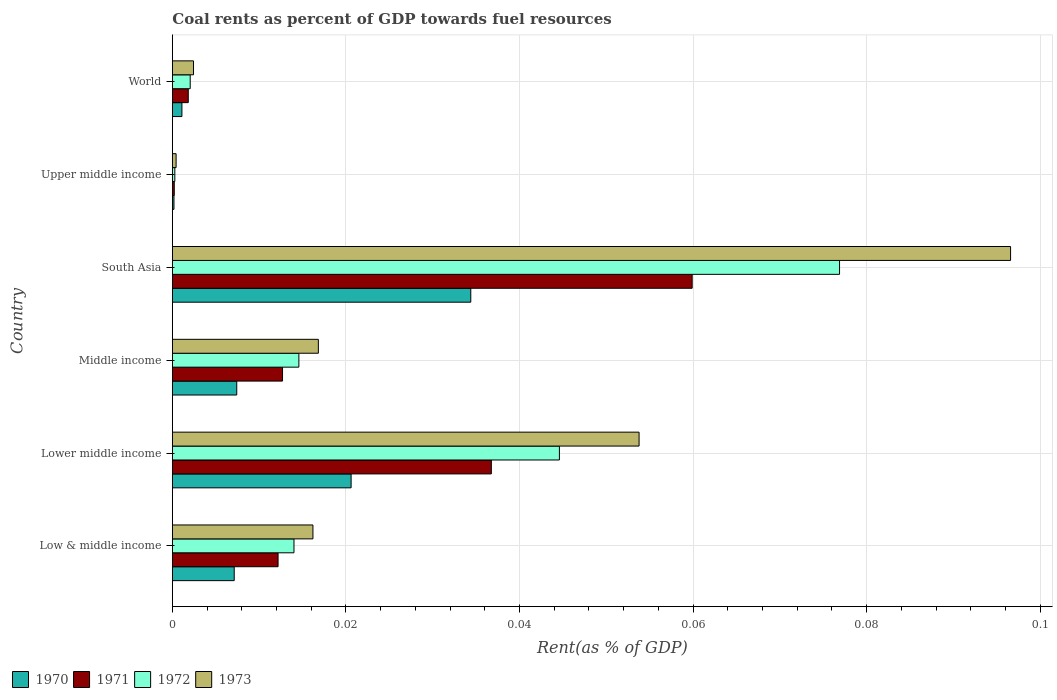How many different coloured bars are there?
Offer a terse response. 4. How many bars are there on the 3rd tick from the top?
Ensure brevity in your answer.  4. How many bars are there on the 4th tick from the bottom?
Your answer should be very brief. 4. What is the label of the 1st group of bars from the top?
Offer a terse response. World. What is the coal rent in 1972 in Middle income?
Make the answer very short. 0.01. Across all countries, what is the maximum coal rent in 1972?
Your answer should be very brief. 0.08. Across all countries, what is the minimum coal rent in 1973?
Provide a succinct answer. 0. In which country was the coal rent in 1973 maximum?
Your response must be concise. South Asia. In which country was the coal rent in 1972 minimum?
Offer a terse response. Upper middle income. What is the total coal rent in 1971 in the graph?
Give a very brief answer. 0.12. What is the difference between the coal rent in 1971 in Low & middle income and that in Lower middle income?
Ensure brevity in your answer.  -0.02. What is the difference between the coal rent in 1972 in World and the coal rent in 1971 in Low & middle income?
Provide a short and direct response. -0.01. What is the average coal rent in 1970 per country?
Make the answer very short. 0.01. What is the difference between the coal rent in 1971 and coal rent in 1973 in Low & middle income?
Offer a very short reply. -0. What is the ratio of the coal rent in 1972 in Middle income to that in World?
Offer a very short reply. 7.09. Is the coal rent in 1972 in Middle income less than that in South Asia?
Provide a succinct answer. Yes. Is the difference between the coal rent in 1971 in Lower middle income and World greater than the difference between the coal rent in 1973 in Lower middle income and World?
Provide a short and direct response. No. What is the difference between the highest and the second highest coal rent in 1971?
Offer a very short reply. 0.02. What is the difference between the highest and the lowest coal rent in 1972?
Your answer should be compact. 0.08. Is it the case that in every country, the sum of the coal rent in 1973 and coal rent in 1970 is greater than the sum of coal rent in 1971 and coal rent in 1972?
Make the answer very short. No. Does the graph contain any zero values?
Keep it short and to the point. No. Does the graph contain grids?
Provide a short and direct response. Yes. How many legend labels are there?
Your response must be concise. 4. What is the title of the graph?
Make the answer very short. Coal rents as percent of GDP towards fuel resources. What is the label or title of the X-axis?
Provide a short and direct response. Rent(as % of GDP). What is the label or title of the Y-axis?
Your answer should be very brief. Country. What is the Rent(as % of GDP) of 1970 in Low & middle income?
Keep it short and to the point. 0.01. What is the Rent(as % of GDP) in 1971 in Low & middle income?
Provide a short and direct response. 0.01. What is the Rent(as % of GDP) in 1972 in Low & middle income?
Your answer should be compact. 0.01. What is the Rent(as % of GDP) of 1973 in Low & middle income?
Offer a very short reply. 0.02. What is the Rent(as % of GDP) in 1970 in Lower middle income?
Offer a terse response. 0.02. What is the Rent(as % of GDP) of 1971 in Lower middle income?
Offer a terse response. 0.04. What is the Rent(as % of GDP) in 1972 in Lower middle income?
Provide a short and direct response. 0.04. What is the Rent(as % of GDP) in 1973 in Lower middle income?
Keep it short and to the point. 0.05. What is the Rent(as % of GDP) of 1970 in Middle income?
Provide a succinct answer. 0.01. What is the Rent(as % of GDP) of 1971 in Middle income?
Make the answer very short. 0.01. What is the Rent(as % of GDP) of 1972 in Middle income?
Give a very brief answer. 0.01. What is the Rent(as % of GDP) in 1973 in Middle income?
Ensure brevity in your answer.  0.02. What is the Rent(as % of GDP) of 1970 in South Asia?
Your response must be concise. 0.03. What is the Rent(as % of GDP) of 1971 in South Asia?
Your answer should be compact. 0.06. What is the Rent(as % of GDP) in 1972 in South Asia?
Make the answer very short. 0.08. What is the Rent(as % of GDP) in 1973 in South Asia?
Ensure brevity in your answer.  0.1. What is the Rent(as % of GDP) of 1970 in Upper middle income?
Make the answer very short. 0. What is the Rent(as % of GDP) of 1971 in Upper middle income?
Give a very brief answer. 0. What is the Rent(as % of GDP) of 1972 in Upper middle income?
Provide a succinct answer. 0. What is the Rent(as % of GDP) in 1973 in Upper middle income?
Provide a short and direct response. 0. What is the Rent(as % of GDP) in 1970 in World?
Offer a very short reply. 0. What is the Rent(as % of GDP) in 1971 in World?
Keep it short and to the point. 0. What is the Rent(as % of GDP) in 1972 in World?
Provide a succinct answer. 0. What is the Rent(as % of GDP) in 1973 in World?
Make the answer very short. 0. Across all countries, what is the maximum Rent(as % of GDP) of 1970?
Your response must be concise. 0.03. Across all countries, what is the maximum Rent(as % of GDP) in 1971?
Offer a terse response. 0.06. Across all countries, what is the maximum Rent(as % of GDP) of 1972?
Your answer should be very brief. 0.08. Across all countries, what is the maximum Rent(as % of GDP) in 1973?
Provide a succinct answer. 0.1. Across all countries, what is the minimum Rent(as % of GDP) of 1970?
Provide a succinct answer. 0. Across all countries, what is the minimum Rent(as % of GDP) of 1971?
Offer a terse response. 0. Across all countries, what is the minimum Rent(as % of GDP) in 1972?
Make the answer very short. 0. Across all countries, what is the minimum Rent(as % of GDP) in 1973?
Give a very brief answer. 0. What is the total Rent(as % of GDP) of 1970 in the graph?
Your response must be concise. 0.07. What is the total Rent(as % of GDP) of 1971 in the graph?
Provide a succinct answer. 0.12. What is the total Rent(as % of GDP) of 1972 in the graph?
Keep it short and to the point. 0.15. What is the total Rent(as % of GDP) of 1973 in the graph?
Keep it short and to the point. 0.19. What is the difference between the Rent(as % of GDP) of 1970 in Low & middle income and that in Lower middle income?
Ensure brevity in your answer.  -0.01. What is the difference between the Rent(as % of GDP) in 1971 in Low & middle income and that in Lower middle income?
Offer a very short reply. -0.02. What is the difference between the Rent(as % of GDP) in 1972 in Low & middle income and that in Lower middle income?
Your response must be concise. -0.03. What is the difference between the Rent(as % of GDP) in 1973 in Low & middle income and that in Lower middle income?
Give a very brief answer. -0.04. What is the difference between the Rent(as % of GDP) in 1970 in Low & middle income and that in Middle income?
Offer a very short reply. -0. What is the difference between the Rent(as % of GDP) in 1971 in Low & middle income and that in Middle income?
Your answer should be compact. -0. What is the difference between the Rent(as % of GDP) of 1972 in Low & middle income and that in Middle income?
Your answer should be compact. -0. What is the difference between the Rent(as % of GDP) in 1973 in Low & middle income and that in Middle income?
Ensure brevity in your answer.  -0. What is the difference between the Rent(as % of GDP) in 1970 in Low & middle income and that in South Asia?
Your answer should be very brief. -0.03. What is the difference between the Rent(as % of GDP) in 1971 in Low & middle income and that in South Asia?
Provide a short and direct response. -0.05. What is the difference between the Rent(as % of GDP) of 1972 in Low & middle income and that in South Asia?
Offer a very short reply. -0.06. What is the difference between the Rent(as % of GDP) of 1973 in Low & middle income and that in South Asia?
Keep it short and to the point. -0.08. What is the difference between the Rent(as % of GDP) of 1970 in Low & middle income and that in Upper middle income?
Your answer should be compact. 0.01. What is the difference between the Rent(as % of GDP) of 1971 in Low & middle income and that in Upper middle income?
Your response must be concise. 0.01. What is the difference between the Rent(as % of GDP) in 1972 in Low & middle income and that in Upper middle income?
Your answer should be compact. 0.01. What is the difference between the Rent(as % of GDP) of 1973 in Low & middle income and that in Upper middle income?
Keep it short and to the point. 0.02. What is the difference between the Rent(as % of GDP) in 1970 in Low & middle income and that in World?
Provide a short and direct response. 0.01. What is the difference between the Rent(as % of GDP) of 1971 in Low & middle income and that in World?
Your answer should be compact. 0.01. What is the difference between the Rent(as % of GDP) in 1972 in Low & middle income and that in World?
Offer a terse response. 0.01. What is the difference between the Rent(as % of GDP) of 1973 in Low & middle income and that in World?
Make the answer very short. 0.01. What is the difference between the Rent(as % of GDP) in 1970 in Lower middle income and that in Middle income?
Offer a very short reply. 0.01. What is the difference between the Rent(as % of GDP) of 1971 in Lower middle income and that in Middle income?
Provide a succinct answer. 0.02. What is the difference between the Rent(as % of GDP) of 1973 in Lower middle income and that in Middle income?
Your answer should be compact. 0.04. What is the difference between the Rent(as % of GDP) in 1970 in Lower middle income and that in South Asia?
Provide a succinct answer. -0.01. What is the difference between the Rent(as % of GDP) in 1971 in Lower middle income and that in South Asia?
Provide a short and direct response. -0.02. What is the difference between the Rent(as % of GDP) in 1972 in Lower middle income and that in South Asia?
Ensure brevity in your answer.  -0.03. What is the difference between the Rent(as % of GDP) of 1973 in Lower middle income and that in South Asia?
Ensure brevity in your answer.  -0.04. What is the difference between the Rent(as % of GDP) in 1970 in Lower middle income and that in Upper middle income?
Your answer should be compact. 0.02. What is the difference between the Rent(as % of GDP) in 1971 in Lower middle income and that in Upper middle income?
Ensure brevity in your answer.  0.04. What is the difference between the Rent(as % of GDP) in 1972 in Lower middle income and that in Upper middle income?
Provide a short and direct response. 0.04. What is the difference between the Rent(as % of GDP) of 1973 in Lower middle income and that in Upper middle income?
Keep it short and to the point. 0.05. What is the difference between the Rent(as % of GDP) of 1970 in Lower middle income and that in World?
Provide a succinct answer. 0.02. What is the difference between the Rent(as % of GDP) in 1971 in Lower middle income and that in World?
Your answer should be very brief. 0.03. What is the difference between the Rent(as % of GDP) in 1972 in Lower middle income and that in World?
Provide a succinct answer. 0.04. What is the difference between the Rent(as % of GDP) of 1973 in Lower middle income and that in World?
Give a very brief answer. 0.05. What is the difference between the Rent(as % of GDP) in 1970 in Middle income and that in South Asia?
Ensure brevity in your answer.  -0.03. What is the difference between the Rent(as % of GDP) in 1971 in Middle income and that in South Asia?
Give a very brief answer. -0.05. What is the difference between the Rent(as % of GDP) in 1972 in Middle income and that in South Asia?
Offer a very short reply. -0.06. What is the difference between the Rent(as % of GDP) in 1973 in Middle income and that in South Asia?
Provide a succinct answer. -0.08. What is the difference between the Rent(as % of GDP) in 1970 in Middle income and that in Upper middle income?
Provide a succinct answer. 0.01. What is the difference between the Rent(as % of GDP) in 1971 in Middle income and that in Upper middle income?
Your response must be concise. 0.01. What is the difference between the Rent(as % of GDP) in 1972 in Middle income and that in Upper middle income?
Give a very brief answer. 0.01. What is the difference between the Rent(as % of GDP) of 1973 in Middle income and that in Upper middle income?
Offer a very short reply. 0.02. What is the difference between the Rent(as % of GDP) in 1970 in Middle income and that in World?
Your answer should be compact. 0.01. What is the difference between the Rent(as % of GDP) in 1971 in Middle income and that in World?
Give a very brief answer. 0.01. What is the difference between the Rent(as % of GDP) in 1972 in Middle income and that in World?
Your response must be concise. 0.01. What is the difference between the Rent(as % of GDP) in 1973 in Middle income and that in World?
Your answer should be compact. 0.01. What is the difference between the Rent(as % of GDP) in 1970 in South Asia and that in Upper middle income?
Keep it short and to the point. 0.03. What is the difference between the Rent(as % of GDP) of 1971 in South Asia and that in Upper middle income?
Offer a terse response. 0.06. What is the difference between the Rent(as % of GDP) in 1972 in South Asia and that in Upper middle income?
Offer a very short reply. 0.08. What is the difference between the Rent(as % of GDP) in 1973 in South Asia and that in Upper middle income?
Provide a succinct answer. 0.1. What is the difference between the Rent(as % of GDP) in 1970 in South Asia and that in World?
Make the answer very short. 0.03. What is the difference between the Rent(as % of GDP) of 1971 in South Asia and that in World?
Your answer should be very brief. 0.06. What is the difference between the Rent(as % of GDP) of 1972 in South Asia and that in World?
Your response must be concise. 0.07. What is the difference between the Rent(as % of GDP) of 1973 in South Asia and that in World?
Provide a succinct answer. 0.09. What is the difference between the Rent(as % of GDP) of 1970 in Upper middle income and that in World?
Your answer should be very brief. -0. What is the difference between the Rent(as % of GDP) of 1971 in Upper middle income and that in World?
Offer a very short reply. -0. What is the difference between the Rent(as % of GDP) of 1972 in Upper middle income and that in World?
Keep it short and to the point. -0. What is the difference between the Rent(as % of GDP) of 1973 in Upper middle income and that in World?
Ensure brevity in your answer.  -0. What is the difference between the Rent(as % of GDP) in 1970 in Low & middle income and the Rent(as % of GDP) in 1971 in Lower middle income?
Offer a very short reply. -0.03. What is the difference between the Rent(as % of GDP) in 1970 in Low & middle income and the Rent(as % of GDP) in 1972 in Lower middle income?
Ensure brevity in your answer.  -0.04. What is the difference between the Rent(as % of GDP) of 1970 in Low & middle income and the Rent(as % of GDP) of 1973 in Lower middle income?
Give a very brief answer. -0.05. What is the difference between the Rent(as % of GDP) in 1971 in Low & middle income and the Rent(as % of GDP) in 1972 in Lower middle income?
Provide a short and direct response. -0.03. What is the difference between the Rent(as % of GDP) in 1971 in Low & middle income and the Rent(as % of GDP) in 1973 in Lower middle income?
Offer a very short reply. -0.04. What is the difference between the Rent(as % of GDP) of 1972 in Low & middle income and the Rent(as % of GDP) of 1973 in Lower middle income?
Your answer should be compact. -0.04. What is the difference between the Rent(as % of GDP) in 1970 in Low & middle income and the Rent(as % of GDP) in 1971 in Middle income?
Ensure brevity in your answer.  -0.01. What is the difference between the Rent(as % of GDP) of 1970 in Low & middle income and the Rent(as % of GDP) of 1972 in Middle income?
Keep it short and to the point. -0.01. What is the difference between the Rent(as % of GDP) in 1970 in Low & middle income and the Rent(as % of GDP) in 1973 in Middle income?
Your answer should be compact. -0.01. What is the difference between the Rent(as % of GDP) of 1971 in Low & middle income and the Rent(as % of GDP) of 1972 in Middle income?
Provide a short and direct response. -0. What is the difference between the Rent(as % of GDP) in 1971 in Low & middle income and the Rent(as % of GDP) in 1973 in Middle income?
Offer a very short reply. -0. What is the difference between the Rent(as % of GDP) in 1972 in Low & middle income and the Rent(as % of GDP) in 1973 in Middle income?
Ensure brevity in your answer.  -0. What is the difference between the Rent(as % of GDP) of 1970 in Low & middle income and the Rent(as % of GDP) of 1971 in South Asia?
Offer a terse response. -0.05. What is the difference between the Rent(as % of GDP) in 1970 in Low & middle income and the Rent(as % of GDP) in 1972 in South Asia?
Your answer should be very brief. -0.07. What is the difference between the Rent(as % of GDP) of 1970 in Low & middle income and the Rent(as % of GDP) of 1973 in South Asia?
Make the answer very short. -0.09. What is the difference between the Rent(as % of GDP) of 1971 in Low & middle income and the Rent(as % of GDP) of 1972 in South Asia?
Give a very brief answer. -0.06. What is the difference between the Rent(as % of GDP) of 1971 in Low & middle income and the Rent(as % of GDP) of 1973 in South Asia?
Your answer should be very brief. -0.08. What is the difference between the Rent(as % of GDP) in 1972 in Low & middle income and the Rent(as % of GDP) in 1973 in South Asia?
Offer a very short reply. -0.08. What is the difference between the Rent(as % of GDP) in 1970 in Low & middle income and the Rent(as % of GDP) in 1971 in Upper middle income?
Your answer should be very brief. 0.01. What is the difference between the Rent(as % of GDP) of 1970 in Low & middle income and the Rent(as % of GDP) of 1972 in Upper middle income?
Your answer should be very brief. 0.01. What is the difference between the Rent(as % of GDP) of 1970 in Low & middle income and the Rent(as % of GDP) of 1973 in Upper middle income?
Provide a succinct answer. 0.01. What is the difference between the Rent(as % of GDP) in 1971 in Low & middle income and the Rent(as % of GDP) in 1972 in Upper middle income?
Keep it short and to the point. 0.01. What is the difference between the Rent(as % of GDP) in 1971 in Low & middle income and the Rent(as % of GDP) in 1973 in Upper middle income?
Provide a short and direct response. 0.01. What is the difference between the Rent(as % of GDP) in 1972 in Low & middle income and the Rent(as % of GDP) in 1973 in Upper middle income?
Keep it short and to the point. 0.01. What is the difference between the Rent(as % of GDP) of 1970 in Low & middle income and the Rent(as % of GDP) of 1971 in World?
Give a very brief answer. 0.01. What is the difference between the Rent(as % of GDP) in 1970 in Low & middle income and the Rent(as % of GDP) in 1972 in World?
Offer a terse response. 0.01. What is the difference between the Rent(as % of GDP) of 1970 in Low & middle income and the Rent(as % of GDP) of 1973 in World?
Your answer should be very brief. 0. What is the difference between the Rent(as % of GDP) of 1971 in Low & middle income and the Rent(as % of GDP) of 1972 in World?
Your response must be concise. 0.01. What is the difference between the Rent(as % of GDP) in 1971 in Low & middle income and the Rent(as % of GDP) in 1973 in World?
Your response must be concise. 0.01. What is the difference between the Rent(as % of GDP) in 1972 in Low & middle income and the Rent(as % of GDP) in 1973 in World?
Your answer should be very brief. 0.01. What is the difference between the Rent(as % of GDP) in 1970 in Lower middle income and the Rent(as % of GDP) in 1971 in Middle income?
Give a very brief answer. 0.01. What is the difference between the Rent(as % of GDP) in 1970 in Lower middle income and the Rent(as % of GDP) in 1972 in Middle income?
Give a very brief answer. 0.01. What is the difference between the Rent(as % of GDP) of 1970 in Lower middle income and the Rent(as % of GDP) of 1973 in Middle income?
Offer a very short reply. 0. What is the difference between the Rent(as % of GDP) in 1971 in Lower middle income and the Rent(as % of GDP) in 1972 in Middle income?
Make the answer very short. 0.02. What is the difference between the Rent(as % of GDP) of 1971 in Lower middle income and the Rent(as % of GDP) of 1973 in Middle income?
Offer a very short reply. 0.02. What is the difference between the Rent(as % of GDP) of 1972 in Lower middle income and the Rent(as % of GDP) of 1973 in Middle income?
Your answer should be compact. 0.03. What is the difference between the Rent(as % of GDP) of 1970 in Lower middle income and the Rent(as % of GDP) of 1971 in South Asia?
Give a very brief answer. -0.04. What is the difference between the Rent(as % of GDP) in 1970 in Lower middle income and the Rent(as % of GDP) in 1972 in South Asia?
Offer a very short reply. -0.06. What is the difference between the Rent(as % of GDP) in 1970 in Lower middle income and the Rent(as % of GDP) in 1973 in South Asia?
Provide a succinct answer. -0.08. What is the difference between the Rent(as % of GDP) of 1971 in Lower middle income and the Rent(as % of GDP) of 1972 in South Asia?
Give a very brief answer. -0.04. What is the difference between the Rent(as % of GDP) in 1971 in Lower middle income and the Rent(as % of GDP) in 1973 in South Asia?
Offer a terse response. -0.06. What is the difference between the Rent(as % of GDP) of 1972 in Lower middle income and the Rent(as % of GDP) of 1973 in South Asia?
Offer a very short reply. -0.05. What is the difference between the Rent(as % of GDP) in 1970 in Lower middle income and the Rent(as % of GDP) in 1971 in Upper middle income?
Offer a very short reply. 0.02. What is the difference between the Rent(as % of GDP) in 1970 in Lower middle income and the Rent(as % of GDP) in 1972 in Upper middle income?
Offer a terse response. 0.02. What is the difference between the Rent(as % of GDP) in 1970 in Lower middle income and the Rent(as % of GDP) in 1973 in Upper middle income?
Make the answer very short. 0.02. What is the difference between the Rent(as % of GDP) in 1971 in Lower middle income and the Rent(as % of GDP) in 1972 in Upper middle income?
Provide a succinct answer. 0.04. What is the difference between the Rent(as % of GDP) in 1971 in Lower middle income and the Rent(as % of GDP) in 1973 in Upper middle income?
Give a very brief answer. 0.04. What is the difference between the Rent(as % of GDP) of 1972 in Lower middle income and the Rent(as % of GDP) of 1973 in Upper middle income?
Ensure brevity in your answer.  0.04. What is the difference between the Rent(as % of GDP) in 1970 in Lower middle income and the Rent(as % of GDP) in 1971 in World?
Your answer should be compact. 0.02. What is the difference between the Rent(as % of GDP) of 1970 in Lower middle income and the Rent(as % of GDP) of 1972 in World?
Make the answer very short. 0.02. What is the difference between the Rent(as % of GDP) of 1970 in Lower middle income and the Rent(as % of GDP) of 1973 in World?
Your response must be concise. 0.02. What is the difference between the Rent(as % of GDP) of 1971 in Lower middle income and the Rent(as % of GDP) of 1972 in World?
Provide a short and direct response. 0.03. What is the difference between the Rent(as % of GDP) in 1971 in Lower middle income and the Rent(as % of GDP) in 1973 in World?
Offer a terse response. 0.03. What is the difference between the Rent(as % of GDP) of 1972 in Lower middle income and the Rent(as % of GDP) of 1973 in World?
Your answer should be very brief. 0.04. What is the difference between the Rent(as % of GDP) of 1970 in Middle income and the Rent(as % of GDP) of 1971 in South Asia?
Ensure brevity in your answer.  -0.05. What is the difference between the Rent(as % of GDP) in 1970 in Middle income and the Rent(as % of GDP) in 1972 in South Asia?
Give a very brief answer. -0.07. What is the difference between the Rent(as % of GDP) in 1970 in Middle income and the Rent(as % of GDP) in 1973 in South Asia?
Give a very brief answer. -0.09. What is the difference between the Rent(as % of GDP) of 1971 in Middle income and the Rent(as % of GDP) of 1972 in South Asia?
Offer a terse response. -0.06. What is the difference between the Rent(as % of GDP) of 1971 in Middle income and the Rent(as % of GDP) of 1973 in South Asia?
Make the answer very short. -0.08. What is the difference between the Rent(as % of GDP) of 1972 in Middle income and the Rent(as % of GDP) of 1973 in South Asia?
Offer a very short reply. -0.08. What is the difference between the Rent(as % of GDP) of 1970 in Middle income and the Rent(as % of GDP) of 1971 in Upper middle income?
Make the answer very short. 0.01. What is the difference between the Rent(as % of GDP) in 1970 in Middle income and the Rent(as % of GDP) in 1972 in Upper middle income?
Your response must be concise. 0.01. What is the difference between the Rent(as % of GDP) in 1970 in Middle income and the Rent(as % of GDP) in 1973 in Upper middle income?
Your response must be concise. 0.01. What is the difference between the Rent(as % of GDP) in 1971 in Middle income and the Rent(as % of GDP) in 1972 in Upper middle income?
Keep it short and to the point. 0.01. What is the difference between the Rent(as % of GDP) in 1971 in Middle income and the Rent(as % of GDP) in 1973 in Upper middle income?
Make the answer very short. 0.01. What is the difference between the Rent(as % of GDP) of 1972 in Middle income and the Rent(as % of GDP) of 1973 in Upper middle income?
Provide a short and direct response. 0.01. What is the difference between the Rent(as % of GDP) of 1970 in Middle income and the Rent(as % of GDP) of 1971 in World?
Your response must be concise. 0.01. What is the difference between the Rent(as % of GDP) in 1970 in Middle income and the Rent(as % of GDP) in 1972 in World?
Your answer should be compact. 0.01. What is the difference between the Rent(as % of GDP) of 1970 in Middle income and the Rent(as % of GDP) of 1973 in World?
Make the answer very short. 0.01. What is the difference between the Rent(as % of GDP) in 1971 in Middle income and the Rent(as % of GDP) in 1972 in World?
Offer a terse response. 0.01. What is the difference between the Rent(as % of GDP) in 1971 in Middle income and the Rent(as % of GDP) in 1973 in World?
Your answer should be compact. 0.01. What is the difference between the Rent(as % of GDP) in 1972 in Middle income and the Rent(as % of GDP) in 1973 in World?
Provide a short and direct response. 0.01. What is the difference between the Rent(as % of GDP) in 1970 in South Asia and the Rent(as % of GDP) in 1971 in Upper middle income?
Offer a terse response. 0.03. What is the difference between the Rent(as % of GDP) of 1970 in South Asia and the Rent(as % of GDP) of 1972 in Upper middle income?
Ensure brevity in your answer.  0.03. What is the difference between the Rent(as % of GDP) of 1970 in South Asia and the Rent(as % of GDP) of 1973 in Upper middle income?
Make the answer very short. 0.03. What is the difference between the Rent(as % of GDP) in 1971 in South Asia and the Rent(as % of GDP) in 1972 in Upper middle income?
Your answer should be compact. 0.06. What is the difference between the Rent(as % of GDP) in 1971 in South Asia and the Rent(as % of GDP) in 1973 in Upper middle income?
Keep it short and to the point. 0.06. What is the difference between the Rent(as % of GDP) in 1972 in South Asia and the Rent(as % of GDP) in 1973 in Upper middle income?
Offer a very short reply. 0.08. What is the difference between the Rent(as % of GDP) of 1970 in South Asia and the Rent(as % of GDP) of 1971 in World?
Ensure brevity in your answer.  0.03. What is the difference between the Rent(as % of GDP) of 1970 in South Asia and the Rent(as % of GDP) of 1972 in World?
Offer a terse response. 0.03. What is the difference between the Rent(as % of GDP) of 1970 in South Asia and the Rent(as % of GDP) of 1973 in World?
Your answer should be compact. 0.03. What is the difference between the Rent(as % of GDP) in 1971 in South Asia and the Rent(as % of GDP) in 1972 in World?
Give a very brief answer. 0.06. What is the difference between the Rent(as % of GDP) in 1971 in South Asia and the Rent(as % of GDP) in 1973 in World?
Your answer should be very brief. 0.06. What is the difference between the Rent(as % of GDP) in 1972 in South Asia and the Rent(as % of GDP) in 1973 in World?
Give a very brief answer. 0.07. What is the difference between the Rent(as % of GDP) of 1970 in Upper middle income and the Rent(as % of GDP) of 1971 in World?
Offer a very short reply. -0. What is the difference between the Rent(as % of GDP) of 1970 in Upper middle income and the Rent(as % of GDP) of 1972 in World?
Give a very brief answer. -0. What is the difference between the Rent(as % of GDP) in 1970 in Upper middle income and the Rent(as % of GDP) in 1973 in World?
Offer a terse response. -0. What is the difference between the Rent(as % of GDP) of 1971 in Upper middle income and the Rent(as % of GDP) of 1972 in World?
Your answer should be very brief. -0. What is the difference between the Rent(as % of GDP) in 1971 in Upper middle income and the Rent(as % of GDP) in 1973 in World?
Your answer should be very brief. -0. What is the difference between the Rent(as % of GDP) of 1972 in Upper middle income and the Rent(as % of GDP) of 1973 in World?
Ensure brevity in your answer.  -0. What is the average Rent(as % of GDP) in 1970 per country?
Offer a terse response. 0.01. What is the average Rent(as % of GDP) of 1971 per country?
Offer a terse response. 0.02. What is the average Rent(as % of GDP) of 1972 per country?
Give a very brief answer. 0.03. What is the average Rent(as % of GDP) in 1973 per country?
Keep it short and to the point. 0.03. What is the difference between the Rent(as % of GDP) in 1970 and Rent(as % of GDP) in 1971 in Low & middle income?
Your response must be concise. -0.01. What is the difference between the Rent(as % of GDP) in 1970 and Rent(as % of GDP) in 1972 in Low & middle income?
Your answer should be compact. -0.01. What is the difference between the Rent(as % of GDP) in 1970 and Rent(as % of GDP) in 1973 in Low & middle income?
Keep it short and to the point. -0.01. What is the difference between the Rent(as % of GDP) in 1971 and Rent(as % of GDP) in 1972 in Low & middle income?
Your response must be concise. -0. What is the difference between the Rent(as % of GDP) in 1971 and Rent(as % of GDP) in 1973 in Low & middle income?
Provide a succinct answer. -0. What is the difference between the Rent(as % of GDP) of 1972 and Rent(as % of GDP) of 1973 in Low & middle income?
Give a very brief answer. -0. What is the difference between the Rent(as % of GDP) in 1970 and Rent(as % of GDP) in 1971 in Lower middle income?
Your answer should be very brief. -0.02. What is the difference between the Rent(as % of GDP) in 1970 and Rent(as % of GDP) in 1972 in Lower middle income?
Offer a terse response. -0.02. What is the difference between the Rent(as % of GDP) of 1970 and Rent(as % of GDP) of 1973 in Lower middle income?
Provide a succinct answer. -0.03. What is the difference between the Rent(as % of GDP) in 1971 and Rent(as % of GDP) in 1972 in Lower middle income?
Offer a very short reply. -0.01. What is the difference between the Rent(as % of GDP) in 1971 and Rent(as % of GDP) in 1973 in Lower middle income?
Keep it short and to the point. -0.02. What is the difference between the Rent(as % of GDP) in 1972 and Rent(as % of GDP) in 1973 in Lower middle income?
Your response must be concise. -0.01. What is the difference between the Rent(as % of GDP) in 1970 and Rent(as % of GDP) in 1971 in Middle income?
Make the answer very short. -0.01. What is the difference between the Rent(as % of GDP) of 1970 and Rent(as % of GDP) of 1972 in Middle income?
Your answer should be very brief. -0.01. What is the difference between the Rent(as % of GDP) in 1970 and Rent(as % of GDP) in 1973 in Middle income?
Your answer should be very brief. -0.01. What is the difference between the Rent(as % of GDP) in 1971 and Rent(as % of GDP) in 1972 in Middle income?
Offer a very short reply. -0. What is the difference between the Rent(as % of GDP) in 1971 and Rent(as % of GDP) in 1973 in Middle income?
Your answer should be compact. -0. What is the difference between the Rent(as % of GDP) in 1972 and Rent(as % of GDP) in 1973 in Middle income?
Ensure brevity in your answer.  -0. What is the difference between the Rent(as % of GDP) of 1970 and Rent(as % of GDP) of 1971 in South Asia?
Offer a terse response. -0.03. What is the difference between the Rent(as % of GDP) of 1970 and Rent(as % of GDP) of 1972 in South Asia?
Your response must be concise. -0.04. What is the difference between the Rent(as % of GDP) of 1970 and Rent(as % of GDP) of 1973 in South Asia?
Keep it short and to the point. -0.06. What is the difference between the Rent(as % of GDP) in 1971 and Rent(as % of GDP) in 1972 in South Asia?
Provide a succinct answer. -0.02. What is the difference between the Rent(as % of GDP) of 1971 and Rent(as % of GDP) of 1973 in South Asia?
Ensure brevity in your answer.  -0.04. What is the difference between the Rent(as % of GDP) of 1972 and Rent(as % of GDP) of 1973 in South Asia?
Your response must be concise. -0.02. What is the difference between the Rent(as % of GDP) of 1970 and Rent(as % of GDP) of 1971 in Upper middle income?
Give a very brief answer. -0. What is the difference between the Rent(as % of GDP) of 1970 and Rent(as % of GDP) of 1972 in Upper middle income?
Give a very brief answer. -0. What is the difference between the Rent(as % of GDP) of 1970 and Rent(as % of GDP) of 1973 in Upper middle income?
Make the answer very short. -0. What is the difference between the Rent(as % of GDP) in 1971 and Rent(as % of GDP) in 1972 in Upper middle income?
Give a very brief answer. -0. What is the difference between the Rent(as % of GDP) of 1971 and Rent(as % of GDP) of 1973 in Upper middle income?
Offer a terse response. -0. What is the difference between the Rent(as % of GDP) of 1972 and Rent(as % of GDP) of 1973 in Upper middle income?
Your response must be concise. -0. What is the difference between the Rent(as % of GDP) of 1970 and Rent(as % of GDP) of 1971 in World?
Your answer should be very brief. -0. What is the difference between the Rent(as % of GDP) in 1970 and Rent(as % of GDP) in 1972 in World?
Your response must be concise. -0. What is the difference between the Rent(as % of GDP) in 1970 and Rent(as % of GDP) in 1973 in World?
Your response must be concise. -0. What is the difference between the Rent(as % of GDP) in 1971 and Rent(as % of GDP) in 1972 in World?
Offer a terse response. -0. What is the difference between the Rent(as % of GDP) of 1971 and Rent(as % of GDP) of 1973 in World?
Offer a terse response. -0. What is the difference between the Rent(as % of GDP) of 1972 and Rent(as % of GDP) of 1973 in World?
Your response must be concise. -0. What is the ratio of the Rent(as % of GDP) of 1970 in Low & middle income to that in Lower middle income?
Offer a terse response. 0.35. What is the ratio of the Rent(as % of GDP) in 1971 in Low & middle income to that in Lower middle income?
Your answer should be very brief. 0.33. What is the ratio of the Rent(as % of GDP) in 1972 in Low & middle income to that in Lower middle income?
Make the answer very short. 0.31. What is the ratio of the Rent(as % of GDP) of 1973 in Low & middle income to that in Lower middle income?
Offer a terse response. 0.3. What is the ratio of the Rent(as % of GDP) of 1970 in Low & middle income to that in Middle income?
Offer a terse response. 0.96. What is the ratio of the Rent(as % of GDP) of 1971 in Low & middle income to that in Middle income?
Ensure brevity in your answer.  0.96. What is the ratio of the Rent(as % of GDP) in 1972 in Low & middle income to that in Middle income?
Give a very brief answer. 0.96. What is the ratio of the Rent(as % of GDP) in 1973 in Low & middle income to that in Middle income?
Provide a succinct answer. 0.96. What is the ratio of the Rent(as % of GDP) of 1970 in Low & middle income to that in South Asia?
Give a very brief answer. 0.21. What is the ratio of the Rent(as % of GDP) of 1971 in Low & middle income to that in South Asia?
Provide a short and direct response. 0.2. What is the ratio of the Rent(as % of GDP) of 1972 in Low & middle income to that in South Asia?
Offer a terse response. 0.18. What is the ratio of the Rent(as % of GDP) of 1973 in Low & middle income to that in South Asia?
Your answer should be compact. 0.17. What is the ratio of the Rent(as % of GDP) in 1970 in Low & middle income to that in Upper middle income?
Your response must be concise. 38.77. What is the ratio of the Rent(as % of GDP) in 1971 in Low & middle income to that in Upper middle income?
Keep it short and to the point. 55.66. What is the ratio of the Rent(as % of GDP) in 1972 in Low & middle income to that in Upper middle income?
Offer a very short reply. 49.28. What is the ratio of the Rent(as % of GDP) of 1973 in Low & middle income to that in Upper middle income?
Ensure brevity in your answer.  37.59. What is the ratio of the Rent(as % of GDP) of 1970 in Low & middle income to that in World?
Offer a very short reply. 6.48. What is the ratio of the Rent(as % of GDP) of 1971 in Low & middle income to that in World?
Offer a terse response. 6.65. What is the ratio of the Rent(as % of GDP) of 1972 in Low & middle income to that in World?
Make the answer very short. 6.82. What is the ratio of the Rent(as % of GDP) of 1973 in Low & middle income to that in World?
Provide a short and direct response. 6.65. What is the ratio of the Rent(as % of GDP) of 1970 in Lower middle income to that in Middle income?
Offer a terse response. 2.78. What is the ratio of the Rent(as % of GDP) in 1971 in Lower middle income to that in Middle income?
Your answer should be very brief. 2.9. What is the ratio of the Rent(as % of GDP) of 1972 in Lower middle income to that in Middle income?
Offer a terse response. 3.06. What is the ratio of the Rent(as % of GDP) of 1973 in Lower middle income to that in Middle income?
Offer a terse response. 3.2. What is the ratio of the Rent(as % of GDP) in 1970 in Lower middle income to that in South Asia?
Your answer should be very brief. 0.6. What is the ratio of the Rent(as % of GDP) of 1971 in Lower middle income to that in South Asia?
Your answer should be very brief. 0.61. What is the ratio of the Rent(as % of GDP) in 1972 in Lower middle income to that in South Asia?
Keep it short and to the point. 0.58. What is the ratio of the Rent(as % of GDP) in 1973 in Lower middle income to that in South Asia?
Make the answer very short. 0.56. What is the ratio of the Rent(as % of GDP) in 1970 in Lower middle income to that in Upper middle income?
Offer a very short reply. 112.03. What is the ratio of the Rent(as % of GDP) of 1971 in Lower middle income to that in Upper middle income?
Your response must be concise. 167.98. What is the ratio of the Rent(as % of GDP) of 1972 in Lower middle income to that in Upper middle income?
Ensure brevity in your answer.  156.82. What is the ratio of the Rent(as % of GDP) in 1973 in Lower middle income to that in Upper middle income?
Give a very brief answer. 124.82. What is the ratio of the Rent(as % of GDP) in 1970 in Lower middle income to that in World?
Give a very brief answer. 18.71. What is the ratio of the Rent(as % of GDP) of 1971 in Lower middle income to that in World?
Offer a very short reply. 20.06. What is the ratio of the Rent(as % of GDP) in 1972 in Lower middle income to that in World?
Offer a very short reply. 21.7. What is the ratio of the Rent(as % of GDP) in 1973 in Lower middle income to that in World?
Offer a very short reply. 22.07. What is the ratio of the Rent(as % of GDP) in 1970 in Middle income to that in South Asia?
Provide a succinct answer. 0.22. What is the ratio of the Rent(as % of GDP) in 1971 in Middle income to that in South Asia?
Your answer should be compact. 0.21. What is the ratio of the Rent(as % of GDP) in 1972 in Middle income to that in South Asia?
Give a very brief answer. 0.19. What is the ratio of the Rent(as % of GDP) of 1973 in Middle income to that in South Asia?
Ensure brevity in your answer.  0.17. What is the ratio of the Rent(as % of GDP) of 1970 in Middle income to that in Upper middle income?
Your answer should be very brief. 40.36. What is the ratio of the Rent(as % of GDP) of 1971 in Middle income to that in Upper middle income?
Provide a short and direct response. 58.01. What is the ratio of the Rent(as % of GDP) in 1972 in Middle income to that in Upper middle income?
Your response must be concise. 51.25. What is the ratio of the Rent(as % of GDP) in 1973 in Middle income to that in Upper middle income?
Offer a very short reply. 39.04. What is the ratio of the Rent(as % of GDP) of 1970 in Middle income to that in World?
Give a very brief answer. 6.74. What is the ratio of the Rent(as % of GDP) in 1971 in Middle income to that in World?
Your response must be concise. 6.93. What is the ratio of the Rent(as % of GDP) in 1972 in Middle income to that in World?
Your response must be concise. 7.09. What is the ratio of the Rent(as % of GDP) of 1973 in Middle income to that in World?
Make the answer very short. 6.91. What is the ratio of the Rent(as % of GDP) of 1970 in South Asia to that in Upper middle income?
Provide a succinct answer. 187.05. What is the ratio of the Rent(as % of GDP) of 1971 in South Asia to that in Upper middle income?
Your answer should be compact. 273.74. What is the ratio of the Rent(as % of GDP) in 1972 in South Asia to that in Upper middle income?
Your response must be concise. 270.32. What is the ratio of the Rent(as % of GDP) of 1973 in South Asia to that in Upper middle income?
Your answer should be very brief. 224.18. What is the ratio of the Rent(as % of GDP) of 1970 in South Asia to that in World?
Give a very brief answer. 31.24. What is the ratio of the Rent(as % of GDP) in 1971 in South Asia to that in World?
Keep it short and to the point. 32.69. What is the ratio of the Rent(as % of GDP) of 1972 in South Asia to that in World?
Offer a very short reply. 37.41. What is the ratio of the Rent(as % of GDP) of 1973 in South Asia to that in World?
Ensure brevity in your answer.  39.65. What is the ratio of the Rent(as % of GDP) of 1970 in Upper middle income to that in World?
Your answer should be very brief. 0.17. What is the ratio of the Rent(as % of GDP) in 1971 in Upper middle income to that in World?
Offer a very short reply. 0.12. What is the ratio of the Rent(as % of GDP) in 1972 in Upper middle income to that in World?
Provide a short and direct response. 0.14. What is the ratio of the Rent(as % of GDP) of 1973 in Upper middle income to that in World?
Provide a short and direct response. 0.18. What is the difference between the highest and the second highest Rent(as % of GDP) in 1970?
Offer a terse response. 0.01. What is the difference between the highest and the second highest Rent(as % of GDP) in 1971?
Give a very brief answer. 0.02. What is the difference between the highest and the second highest Rent(as % of GDP) of 1972?
Offer a terse response. 0.03. What is the difference between the highest and the second highest Rent(as % of GDP) in 1973?
Make the answer very short. 0.04. What is the difference between the highest and the lowest Rent(as % of GDP) in 1970?
Your response must be concise. 0.03. What is the difference between the highest and the lowest Rent(as % of GDP) in 1971?
Provide a short and direct response. 0.06. What is the difference between the highest and the lowest Rent(as % of GDP) in 1972?
Give a very brief answer. 0.08. What is the difference between the highest and the lowest Rent(as % of GDP) in 1973?
Offer a very short reply. 0.1. 